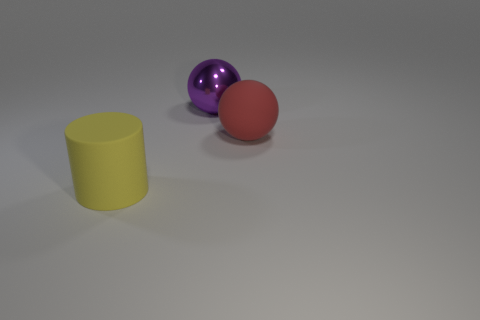What is the color of the other object that is the same shape as the purple object?
Provide a succinct answer. Red. Does the purple shiny object have the same shape as the large yellow object?
Offer a terse response. No. The other metallic object that is the same shape as the red object is what size?
Offer a very short reply. Large. What number of yellow blocks have the same material as the yellow cylinder?
Make the answer very short. 0. What number of objects are purple things or yellow metallic cubes?
Your response must be concise. 1. Is there a yellow object right of the rubber thing behind the big yellow matte cylinder?
Your answer should be compact. No. Is the number of matte spheres that are in front of the large purple thing greater than the number of big balls that are on the left side of the large yellow cylinder?
Your answer should be compact. Yes. There is a large object that is in front of the red rubber sphere; is it the same color as the sphere that is in front of the large purple object?
Your answer should be compact. No. There is a big metallic sphere; are there any red objects behind it?
Your answer should be very brief. No. What is the large red ball made of?
Ensure brevity in your answer.  Rubber. 